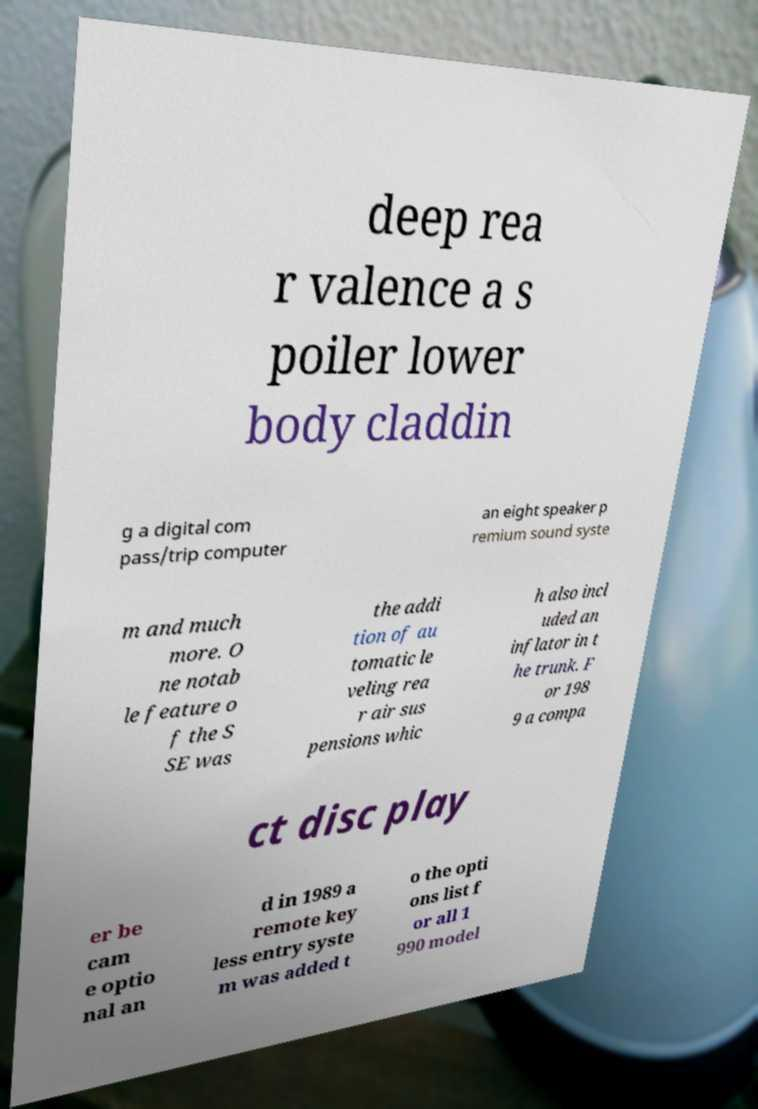Please identify and transcribe the text found in this image. deep rea r valence a s poiler lower body claddin g a digital com pass/trip computer an eight speaker p remium sound syste m and much more. O ne notab le feature o f the S SE was the addi tion of au tomatic le veling rea r air sus pensions whic h also incl uded an inflator in t he trunk. F or 198 9 a compa ct disc play er be cam e optio nal an d in 1989 a remote key less entry syste m was added t o the opti ons list f or all 1 990 model 